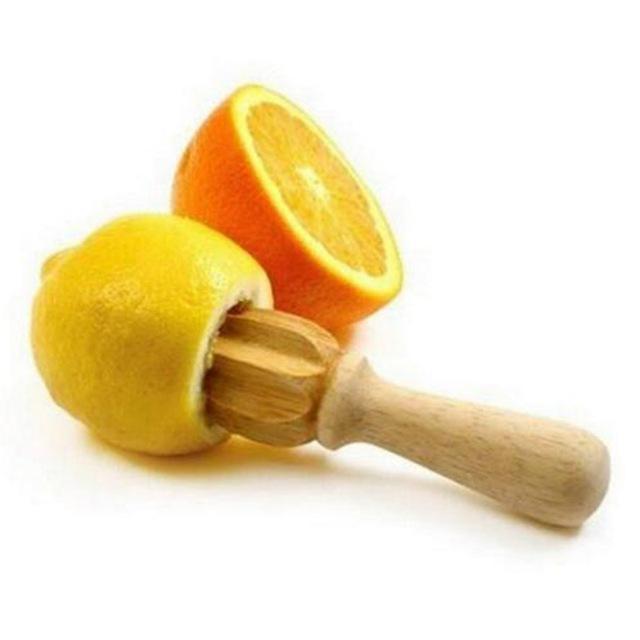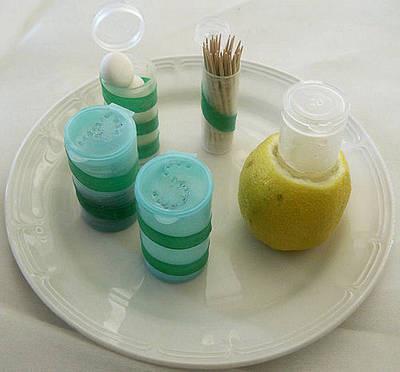The first image is the image on the left, the second image is the image on the right. Given the left and right images, does the statement "In at least one image there are two halves of a lemon." hold true? Answer yes or no. No. 